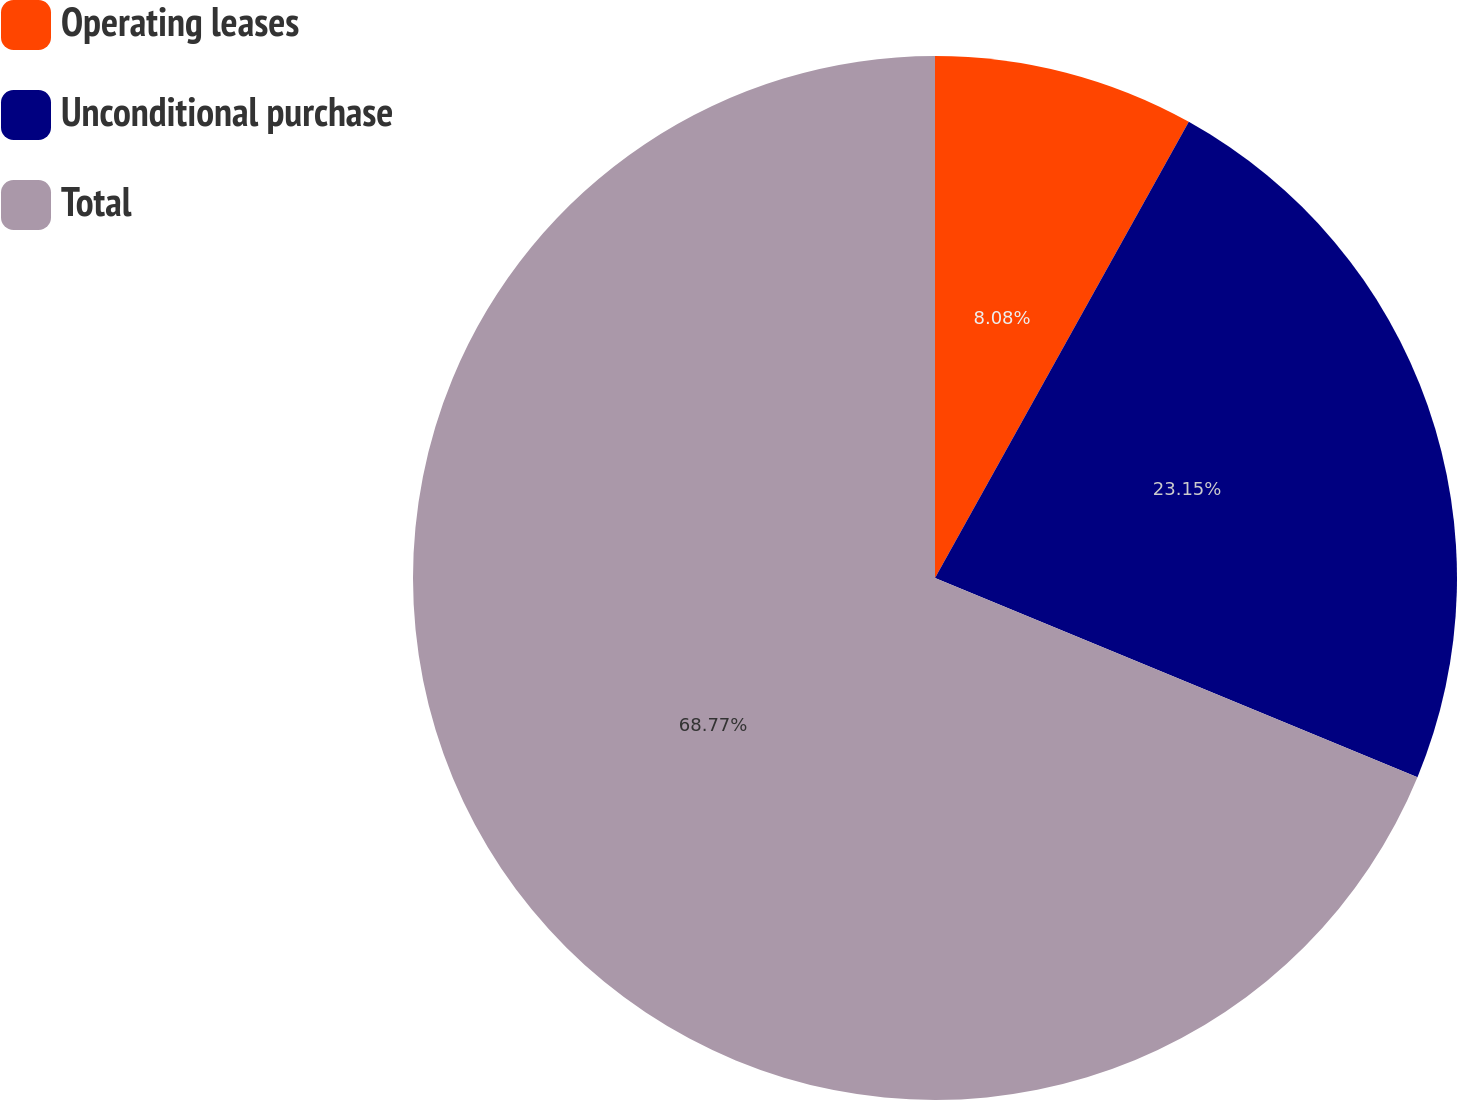Convert chart to OTSL. <chart><loc_0><loc_0><loc_500><loc_500><pie_chart><fcel>Operating leases<fcel>Unconditional purchase<fcel>Total<nl><fcel>8.08%<fcel>23.15%<fcel>68.76%<nl></chart> 